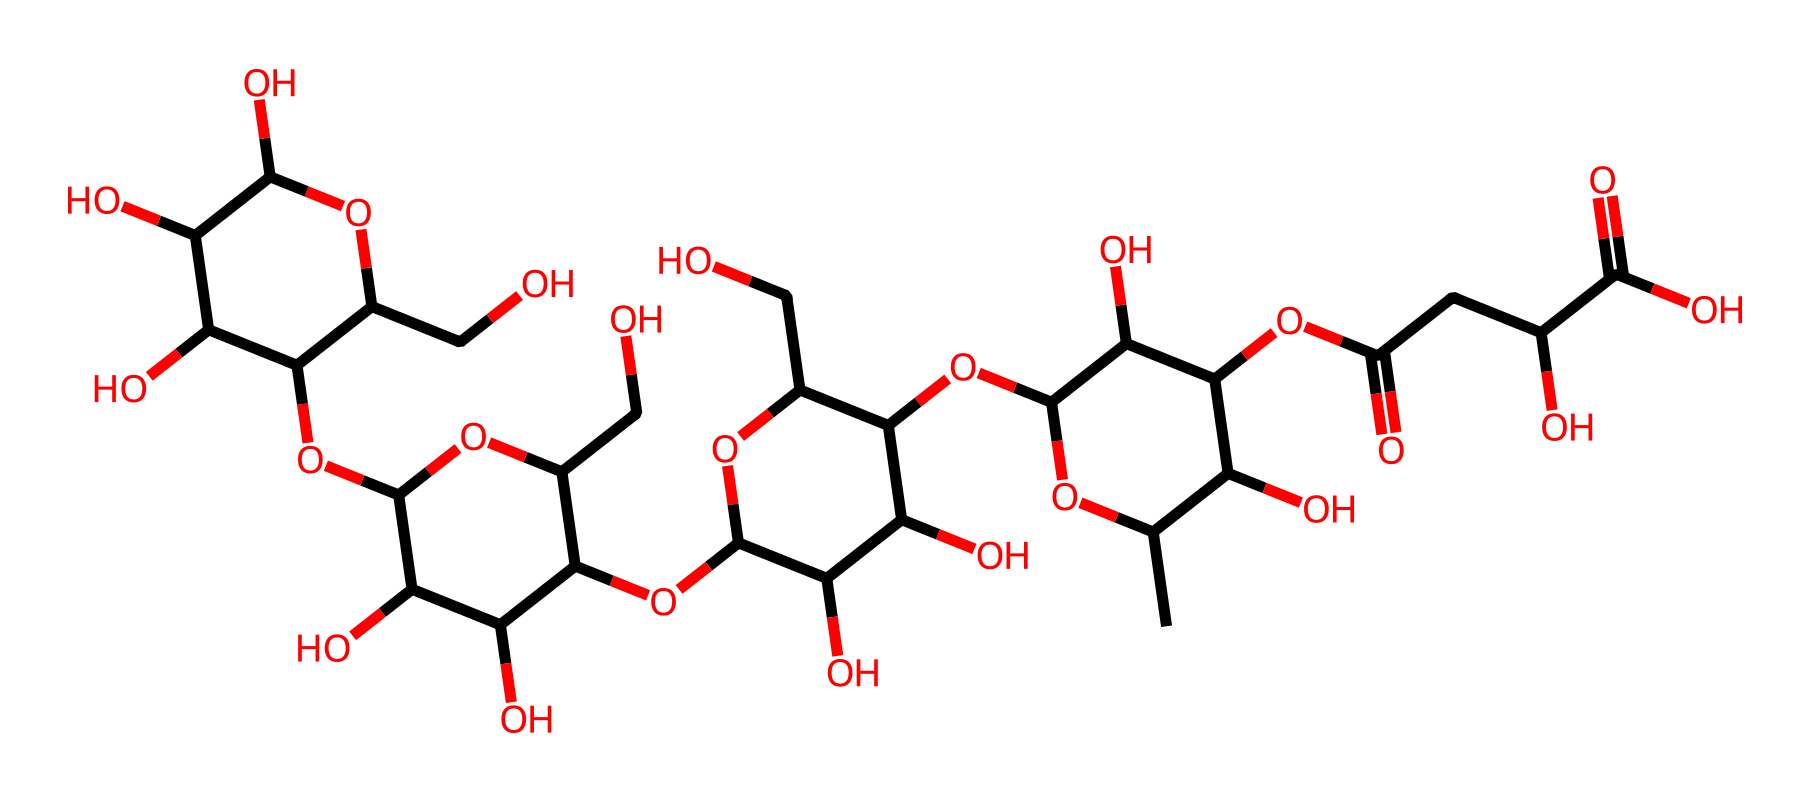What is the molecular formula of xanthan gum? To determine the molecular formula, we need to count the number of carbon (C), hydrogen (H), and oxygen (O) atoms in the provided SMILES. The structure contains 35 carbon atoms, 50 hydrogen atoms, and 29 oxygen atoms, leading to the formula C35H50O29.
Answer: C35H50O29 How many rings are present in xanthan gum's structure? By analyzing the chemical structure represented in the SMILES, we can identify the cyclic portions of the molecule. Xanthan gum includes multiple ring structures, specifically four six-membered rings based on the count of the ring closures in its composition.
Answer: 4 What type of glycosidic bonds are present in xanthan gum? In xanthan gum, the sugar units are linked primarily through β-glycosidic bonds, which can be identified by examining the connections between the sugar units in the structure. These specific connections support the non-Newtonian behavior of the fluid.
Answer: β-glycosidic What is the primary role of xanthan gum as a food additive? Xanthan gum is primarily used as a thickening agent in food formulations. This is evident from its ability to increase viscosity, which is a characteristic of its non-Newtonian flow behavior.
Answer: thickening agent How does xanthan gum exhibit non-Newtonian properties? Xanthan gum demonstrates shear-thinning behavior, which means that its viscosity decreases under shear stress. This property is indicated by its structural composition, where the complex polysaccharide chains can realign under stress, leading to changes in flow behavior.
Answer: shear-thinning What characteristic functional groups are prominent in xanthan gum? The structure reveals multiple hydroxyl (-OH) groups, which are indicative of the molecule's ability to form hydrogen bonds, affecting its solubility and thickening properties in solution.
Answer: hydroxyl groups 